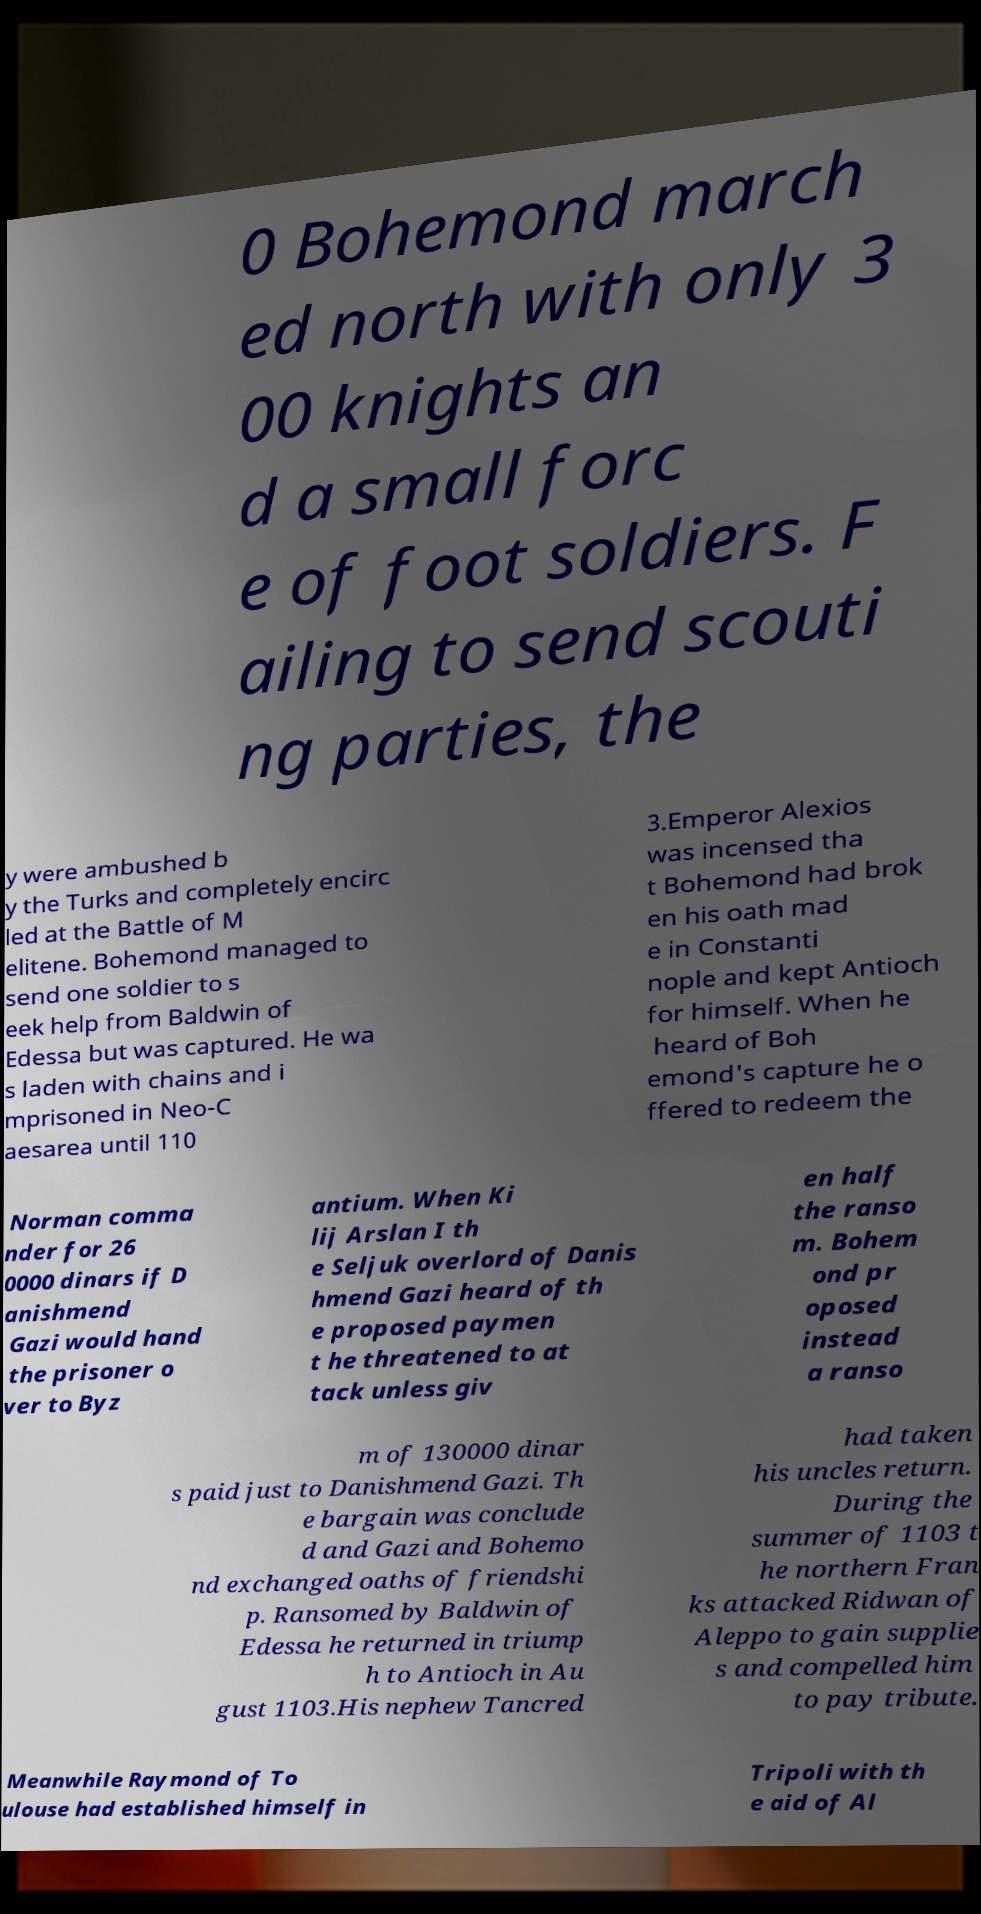I need the written content from this picture converted into text. Can you do that? 0 Bohemond march ed north with only 3 00 knights an d a small forc e of foot soldiers. F ailing to send scouti ng parties, the y were ambushed b y the Turks and completely encirc led at the Battle of M elitene. Bohemond managed to send one soldier to s eek help from Baldwin of Edessa but was captured. He wa s laden with chains and i mprisoned in Neo-C aesarea until 110 3.Emperor Alexios was incensed tha t Bohemond had brok en his oath mad e in Constanti nople and kept Antioch for himself. When he heard of Boh emond's capture he o ffered to redeem the Norman comma nder for 26 0000 dinars if D anishmend Gazi would hand the prisoner o ver to Byz antium. When Ki lij Arslan I th e Seljuk overlord of Danis hmend Gazi heard of th e proposed paymen t he threatened to at tack unless giv en half the ranso m. Bohem ond pr oposed instead a ranso m of 130000 dinar s paid just to Danishmend Gazi. Th e bargain was conclude d and Gazi and Bohemo nd exchanged oaths of friendshi p. Ransomed by Baldwin of Edessa he returned in triump h to Antioch in Au gust 1103.His nephew Tancred had taken his uncles return. During the summer of 1103 t he northern Fran ks attacked Ridwan of Aleppo to gain supplie s and compelled him to pay tribute. Meanwhile Raymond of To ulouse had established himself in Tripoli with th e aid of Al 